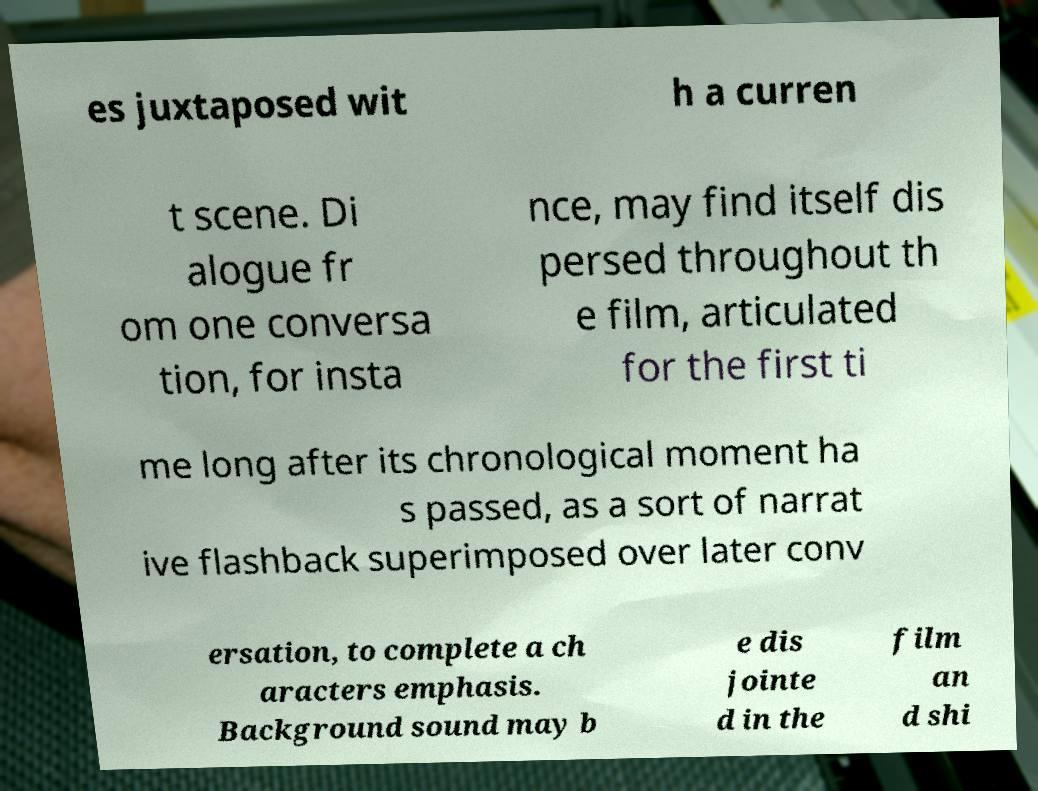There's text embedded in this image that I need extracted. Can you transcribe it verbatim? es juxtaposed wit h a curren t scene. Di alogue fr om one conversa tion, for insta nce, may find itself dis persed throughout th e film, articulated for the first ti me long after its chronological moment ha s passed, as a sort of narrat ive flashback superimposed over later conv ersation, to complete a ch aracters emphasis. Background sound may b e dis jointe d in the film an d shi 